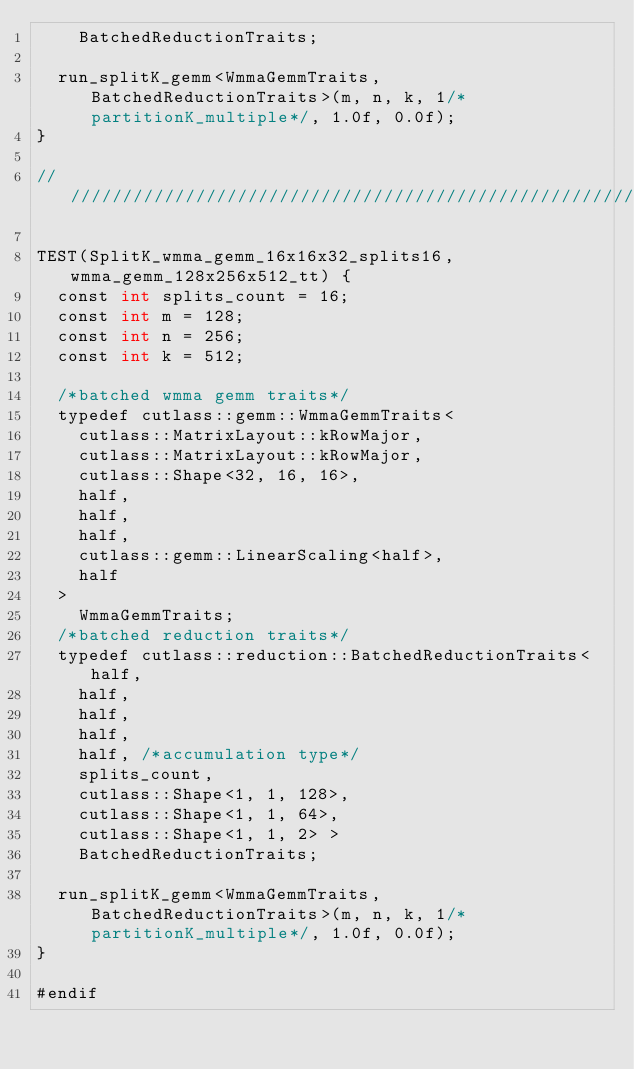Convert code to text. <code><loc_0><loc_0><loc_500><loc_500><_Cuda_>    BatchedReductionTraits;

  run_splitK_gemm<WmmaGemmTraits, BatchedReductionTraits>(m, n, k, 1/*partitionK_multiple*/, 1.0f, 0.0f);
}

////////////////////////////////////////////////////////////////////////////////////////////////////

TEST(SplitK_wmma_gemm_16x16x32_splits16, wmma_gemm_128x256x512_tt) {
  const int splits_count = 16;
  const int m = 128;
  const int n = 256;
  const int k = 512;

  /*batched wmma gemm traits*/
  typedef cutlass::gemm::WmmaGemmTraits<
    cutlass::MatrixLayout::kRowMajor,
    cutlass::MatrixLayout::kRowMajor,
    cutlass::Shape<32, 16, 16>,
    half,
    half,
    half,
    cutlass::gemm::LinearScaling<half>,
    half
  >
    WmmaGemmTraits;
  /*batched reduction traits*/
  typedef cutlass::reduction::BatchedReductionTraits<half,
    half,
    half,
    half,
    half, /*accumulation type*/
    splits_count,
    cutlass::Shape<1, 1, 128>,
    cutlass::Shape<1, 1, 64>,
    cutlass::Shape<1, 1, 2> >
    BatchedReductionTraits;

  run_splitK_gemm<WmmaGemmTraits, BatchedReductionTraits>(m, n, k, 1/*partitionK_multiple*/, 1.0f, 0.0f);
}

#endif
</code> 